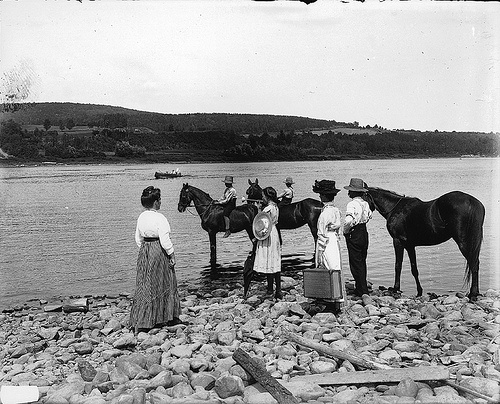Describe the objects in this image and their specific colors. I can see horse in gray, black, darkgray, and lightgray tones, people in gray, black, lightgray, and darkgray tones, people in gray, lightgray, black, and darkgray tones, horse in gray, black, darkgray, and lightgray tones, and people in gray, black, lightgray, and darkgray tones in this image. 